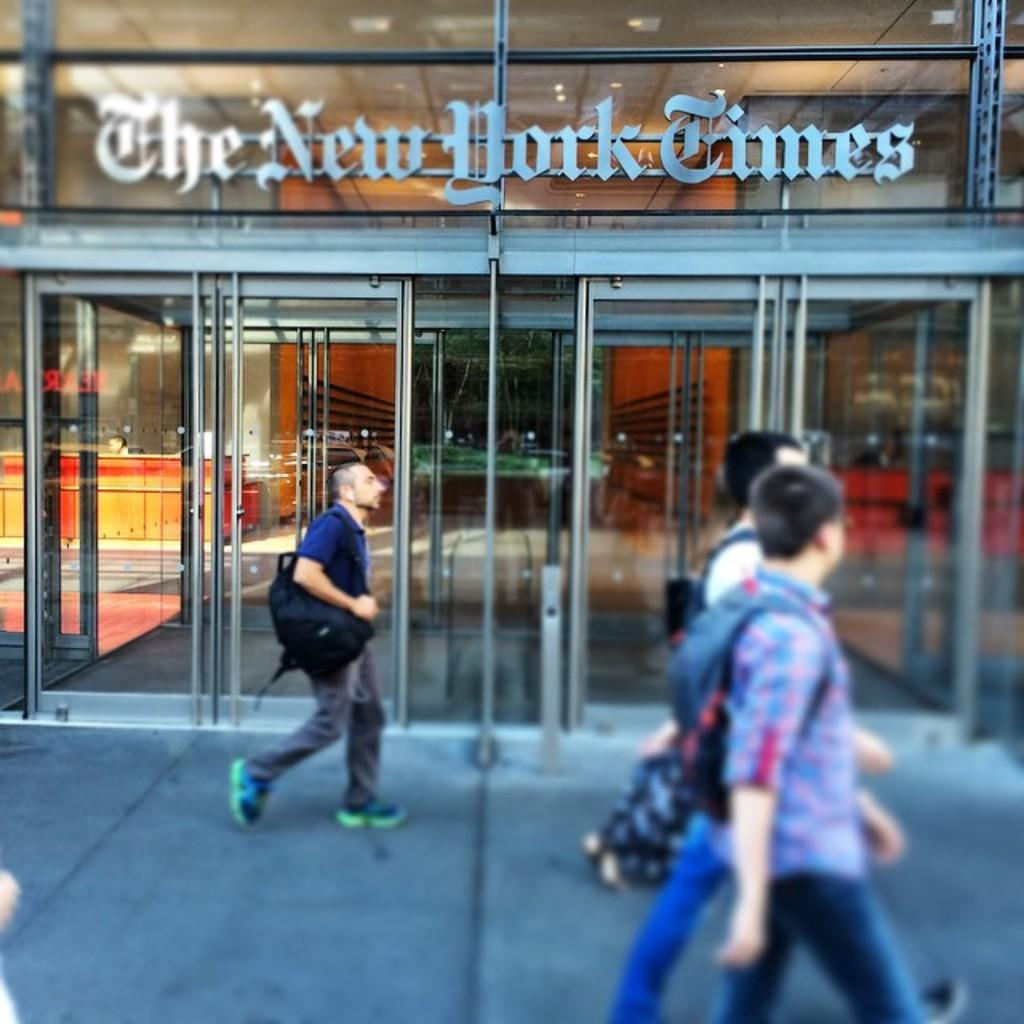What is happening in front of the shop in the image? There are people walking in front of the shop. What type of doors does the shop have? The shop has glass doors. What is the name of the shop? The name of the shop is "The New York Times." Is there a hospital located inside the shop? There is no information about a hospital in the image or the provided facts. What force is causing the people to walk in front of the shop? There is no information about a force causing the people to walk in the image or the provided facts. 